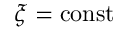<formula> <loc_0><loc_0><loc_500><loc_500>\xi = c o n s t</formula> 